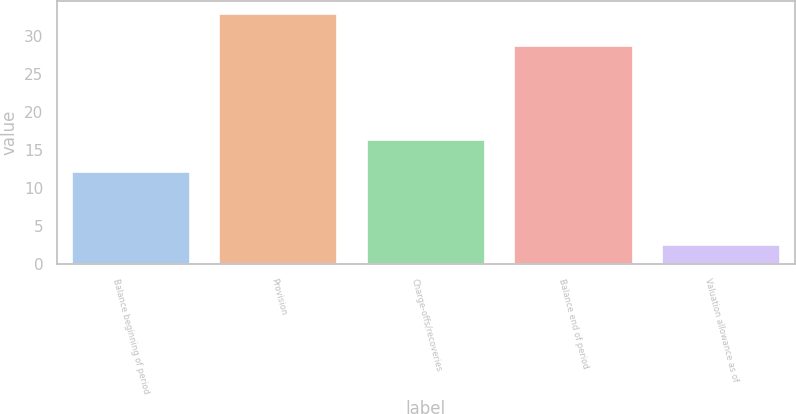Convert chart. <chart><loc_0><loc_0><loc_500><loc_500><bar_chart><fcel>Balance beginning of period<fcel>Provision<fcel>Charge-offs/recoveries<fcel>Balance end of period<fcel>Valuation allowance as of<nl><fcel>12.1<fcel>32.9<fcel>16.3<fcel>28.7<fcel>2.5<nl></chart> 